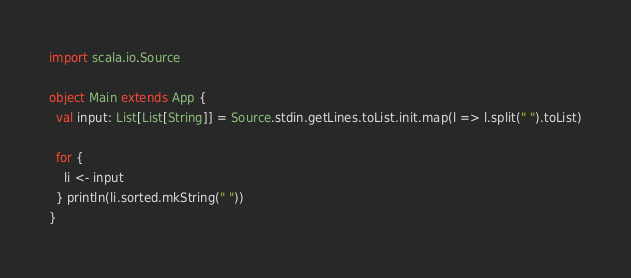<code> <loc_0><loc_0><loc_500><loc_500><_Scala_>import scala.io.Source

object Main extends App {
  val input: List[List[String]] = Source.stdin.getLines.toList.init.map(l => l.split(" ").toList)

  for {
    li <- input
  } println(li.sorted.mkString(" "))
}</code> 